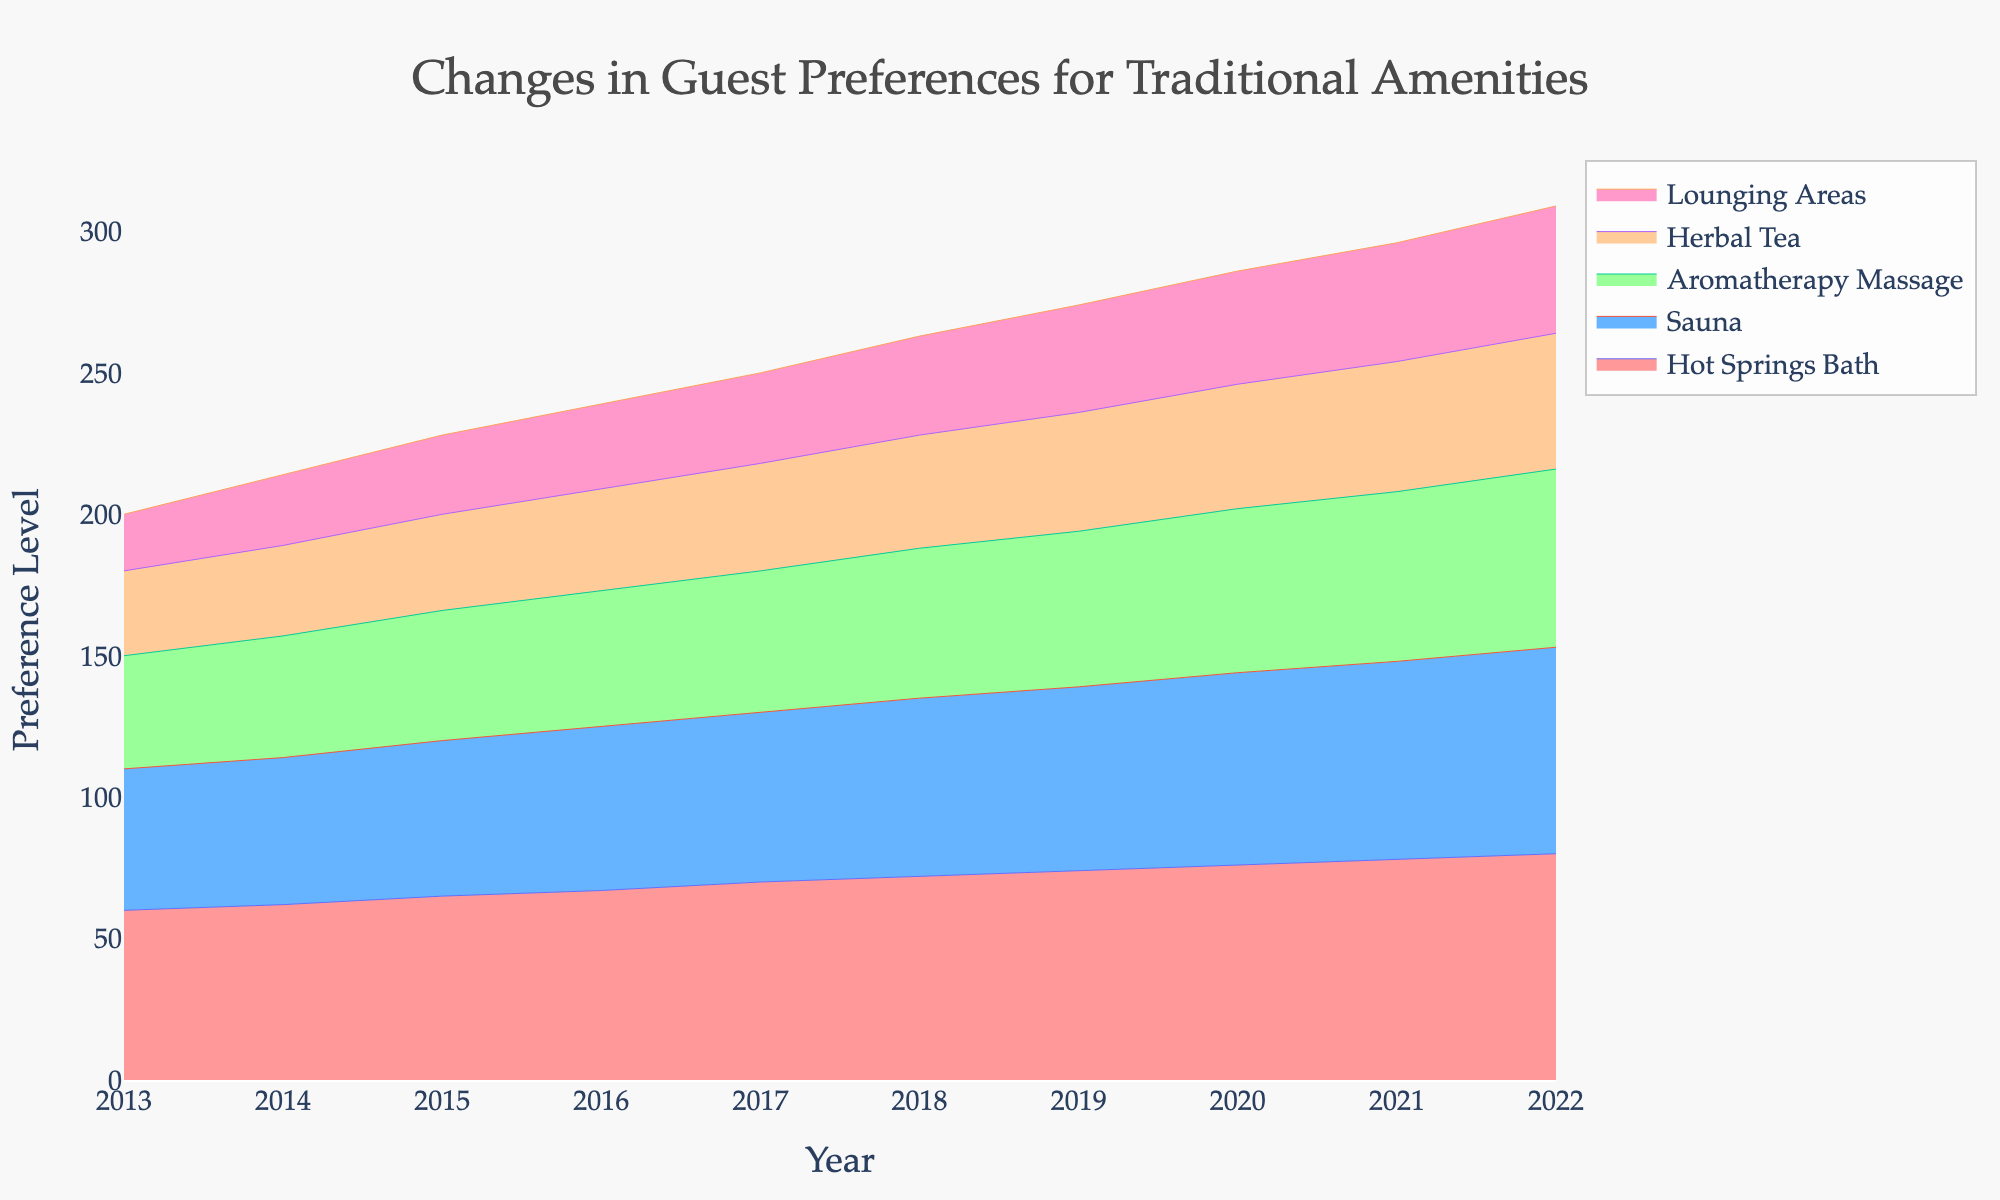What is the title of the figure? The title of a figure is usually displayed prominently at the top and serves as a summary of what the chart is about. In this case, it can be found by looking at the text centered at the top of the figure.
Answer: Changes in Guest Preferences for Traditional Amenities Which amenity had the highest preference level in 2022? To find this, observe the y-values for each amenity in the year 2022. The highest line in that year represents the most preferred amenity.
Answer: Hot Springs Bath What trend do we see in the preference for Sauna from 2013 to 2022? Investigate the line representing Sauna from left to right, noticing if it generally goes up, down, or stays constant. The trend can be identified by observing changes in y-values over time.
Answer: Increasing How does the preference for Lounging Areas in 2015 compare to Hot Springs Bath in the same year? Locate the year 2015 on the x-axis, and compare the y-values for both Lounging Areas and Hot Springs Bath.
Answer: Lounging Areas is less than Hot Springs Bath By how much did the preference for Aromatherapy Massage change from 2014 to 2022? Find the y-values for Aromatherapy Massage in both 2014 and 2022. Subtract the 2014 value from the 2022 value to get the change in preference.
Answer: 20 What is the sum of preference levels for all amenities in 2018? For the year 2018, add the y-values for Hot Springs Bath, Sauna, Aromatherapy Massage, Herbal Tea, and Lounging Areas. The sum provides the total preference level for that year.
Answer: 263 Which amenity saw the smallest increase in preference from 2013 to 2022? Calculate the difference in y-values from 2013 to 2022 for all amenities. The amenity with the smallest difference has the smallest increase.
Answer: Herbal Tea How does the preference for Herbal Tea change in the period from 2013 to 2022 compared to Sauna? Calculate the total increase in preference for both Herbal Tea and Sauna from 2013 to 2022. Compare the two values to identify how their changes relate to one another.
Answer: The change in preference for Herbal Tea is smaller than that for Sauna What is the average preference level for Hot Springs Bath over the decade? Sum the y-values for Hot Springs Bath from 2013 to 2022 and then divide the sum by the number of years (10) to get the average.
Answer: 70 Which amenity had the most significant visual change in its preference trend from the midpoint of the decade to the end? Identify the midpoint (around 2017) and compare the trend lines from 2017 to 2022 for each amenity. The amenity with the largest change in trend visually indicates significant change.
Answer: Hot Springs Bath 